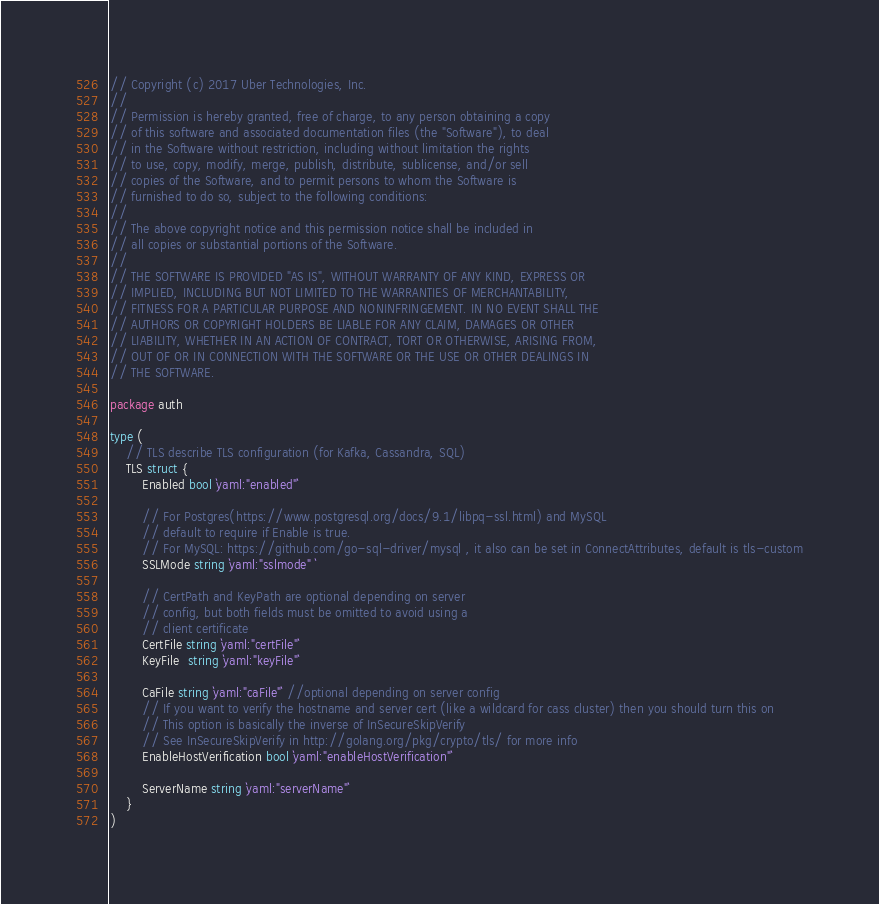<code> <loc_0><loc_0><loc_500><loc_500><_Go_>// Copyright (c) 2017 Uber Technologies, Inc.
//
// Permission is hereby granted, free of charge, to any person obtaining a copy
// of this software and associated documentation files (the "Software"), to deal
// in the Software without restriction, including without limitation the rights
// to use, copy, modify, merge, publish, distribute, sublicense, and/or sell
// copies of the Software, and to permit persons to whom the Software is
// furnished to do so, subject to the following conditions:
//
// The above copyright notice and this permission notice shall be included in
// all copies or substantial portions of the Software.
//
// THE SOFTWARE IS PROVIDED "AS IS", WITHOUT WARRANTY OF ANY KIND, EXPRESS OR
// IMPLIED, INCLUDING BUT NOT LIMITED TO THE WARRANTIES OF MERCHANTABILITY,
// FITNESS FOR A PARTICULAR PURPOSE AND NONINFRINGEMENT. IN NO EVENT SHALL THE
// AUTHORS OR COPYRIGHT HOLDERS BE LIABLE FOR ANY CLAIM, DAMAGES OR OTHER
// LIABILITY, WHETHER IN AN ACTION OF CONTRACT, TORT OR OTHERWISE, ARISING FROM,
// OUT OF OR IN CONNECTION WITH THE SOFTWARE OR THE USE OR OTHER DEALINGS IN
// THE SOFTWARE.

package auth

type (
	// TLS describe TLS configuration (for Kafka, Cassandra, SQL)
	TLS struct {
		Enabled bool `yaml:"enabled"`

		// For Postgres(https://www.postgresql.org/docs/9.1/libpq-ssl.html) and MySQL
		// default to require if Enable is true.
		// For MySQL: https://github.com/go-sql-driver/mysql , it also can be set in ConnectAttributes, default is tls-custom
		SSLMode string `yaml:"sslmode" `

		// CertPath and KeyPath are optional depending on server
		// config, but both fields must be omitted to avoid using a
		// client certificate
		CertFile string `yaml:"certFile"`
		KeyFile  string `yaml:"keyFile"`

		CaFile string `yaml:"caFile"` //optional depending on server config
		// If you want to verify the hostname and server cert (like a wildcard for cass cluster) then you should turn this on
		// This option is basically the inverse of InSecureSkipVerify
		// See InSecureSkipVerify in http://golang.org/pkg/crypto/tls/ for more info
		EnableHostVerification bool `yaml:"enableHostVerification"`

		ServerName string `yaml:"serverName"`
	}
)
</code> 